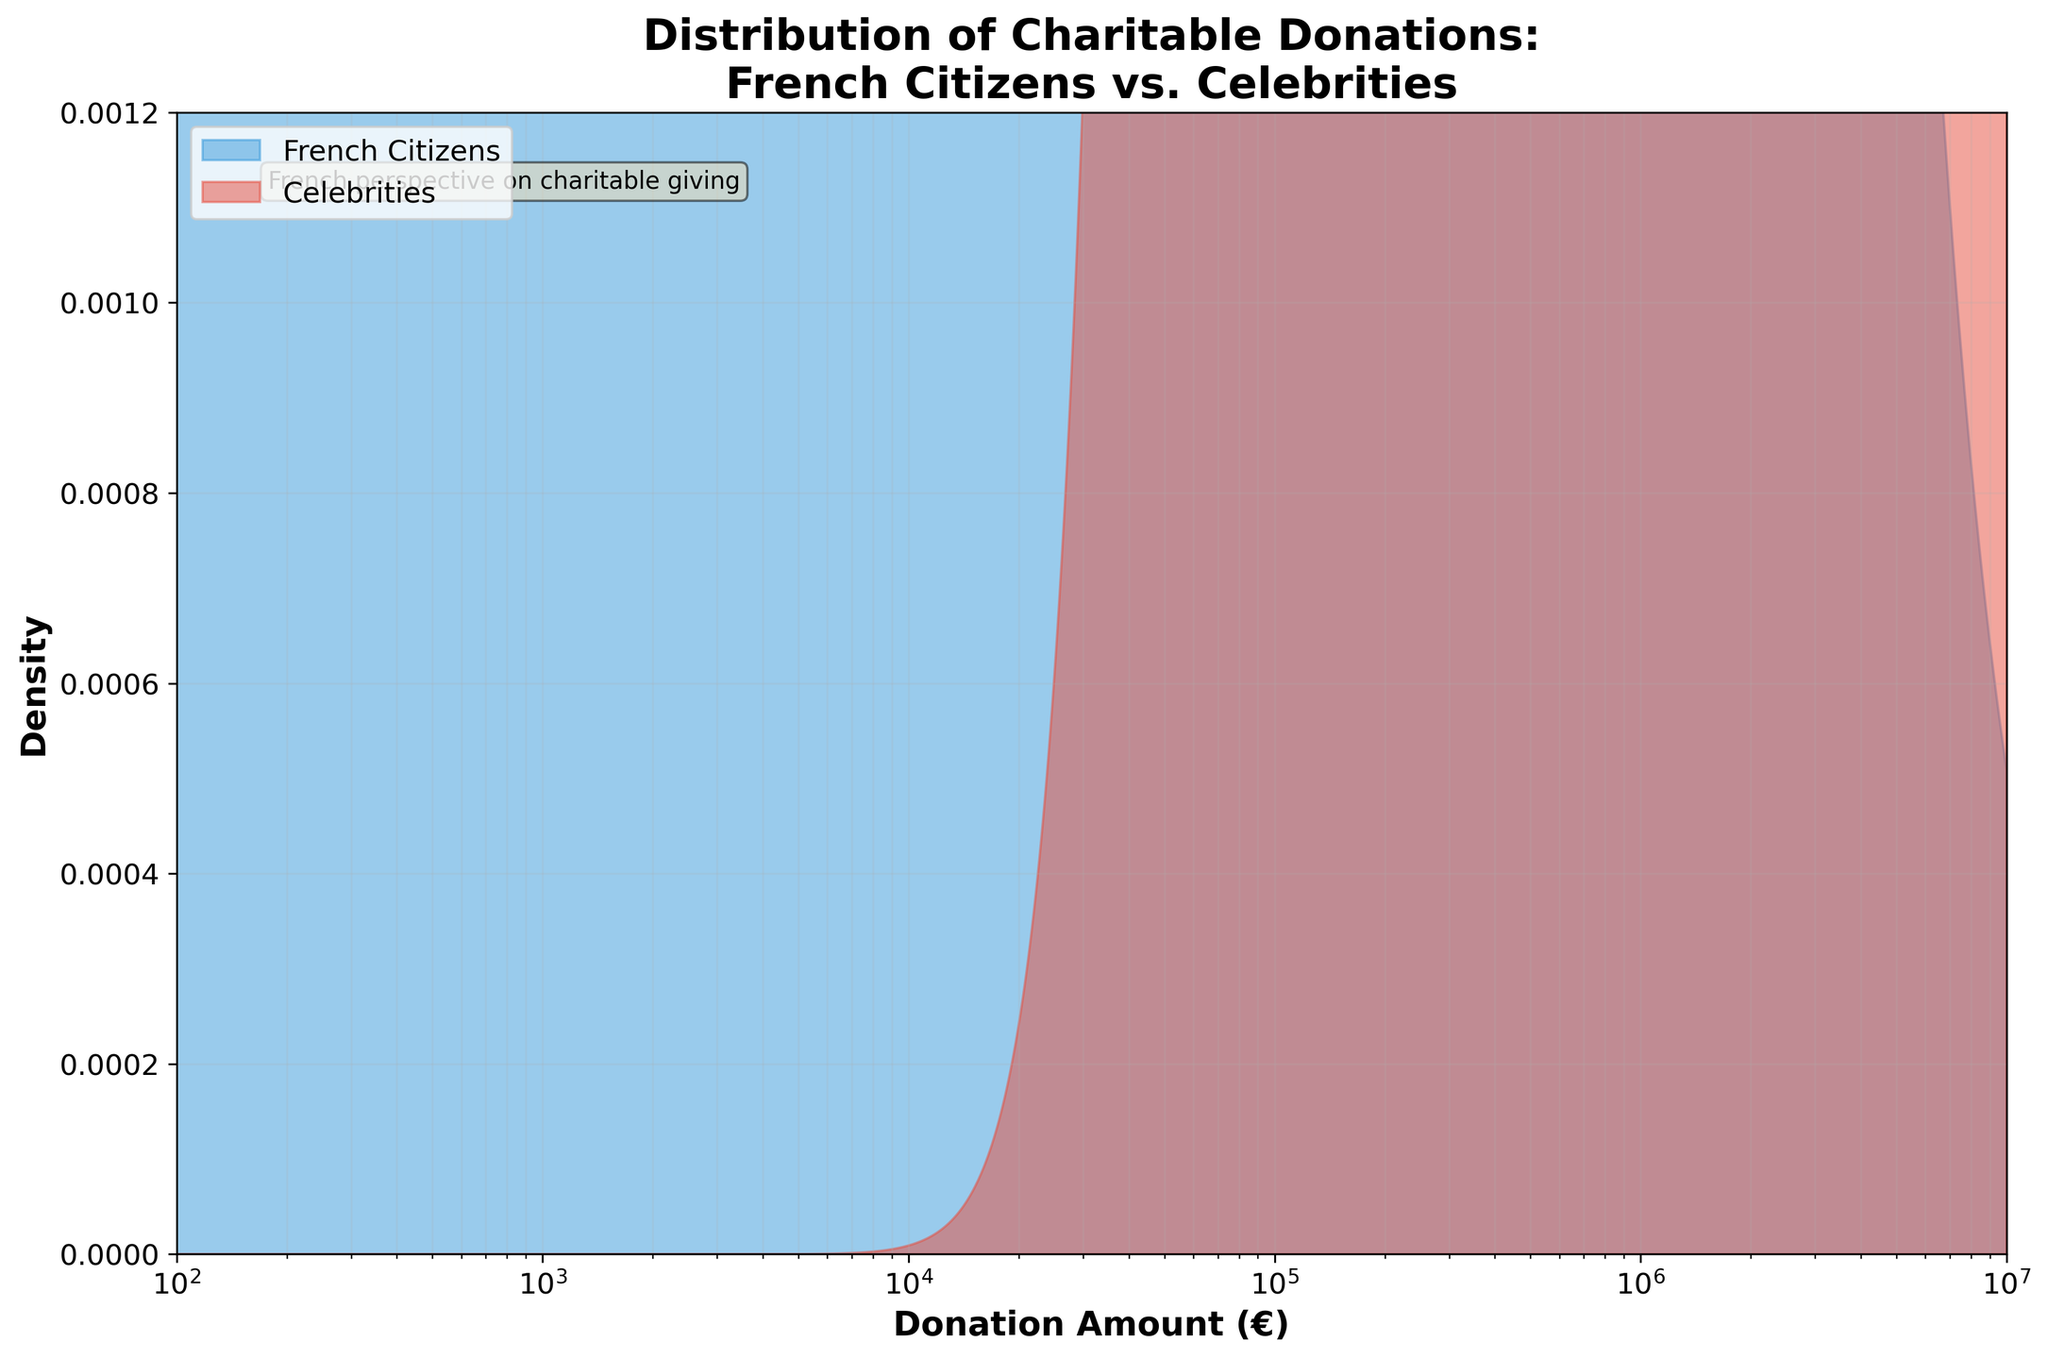What is the title of the figure? The title is located at the top of the plot and provides a summary of what the plot represents.
Answer: Distribution of Charitable Donations: French Citizens vs. Celebrities What does the x-axis represent? The x-axis is the horizontal axis of the plot and represents the variable that is being measured. In this case, it shows the donation amounts in euros.
Answer: Donation Amount (€) Which group has a wider range of donation amounts? To determine this, examine the x-axis range where each group's density is nonzero. The French Citizens' donations range from around €100 to €100,000, while Celebrities' donations range from around €500,000 to €10,000,000. Celebrities have a wider range.
Answer: Celebrities What is the color of the area representing French Citizens? The color can be identified by looking at the legend in the plot. The area representing French Citizens is filled with a blue color.
Answer: Blue For which group is the density peak higher? To find the group with a higher density peak, compare the height of the filled areas on the plot. The peak density for French Citizens is visibly higher than for Celebrities.
Answer: French Citizens How do the donation amounts compare at the €1,000 mark for both groups? Locate the €1,000 mark on the x-axis and observe the density values for both groups at this point. French Citizens have a significant density at this donation amount, whereas Celebrities have almost none.
Answer: French Citizens have higher density What is the difference in the maximum donation amounts between the two groups? The maximum donation for French Citizens is approximately €100,000. For Celebrities, it is €10,000,000. Calculate the difference: €10,000,000 - €100,000 = €9,900,000.
Answer: €9,900,000 What can we infer about the general trend of donation amounts from French Citizens compared to Celebrities? The general trend shows that French Citizens tend to make smaller, more frequent donations, while Celebrities make fewer but significantly larger donations.
Answer: French Citizens make smaller, frequent donations; Celebrities make larger, fewer donations 